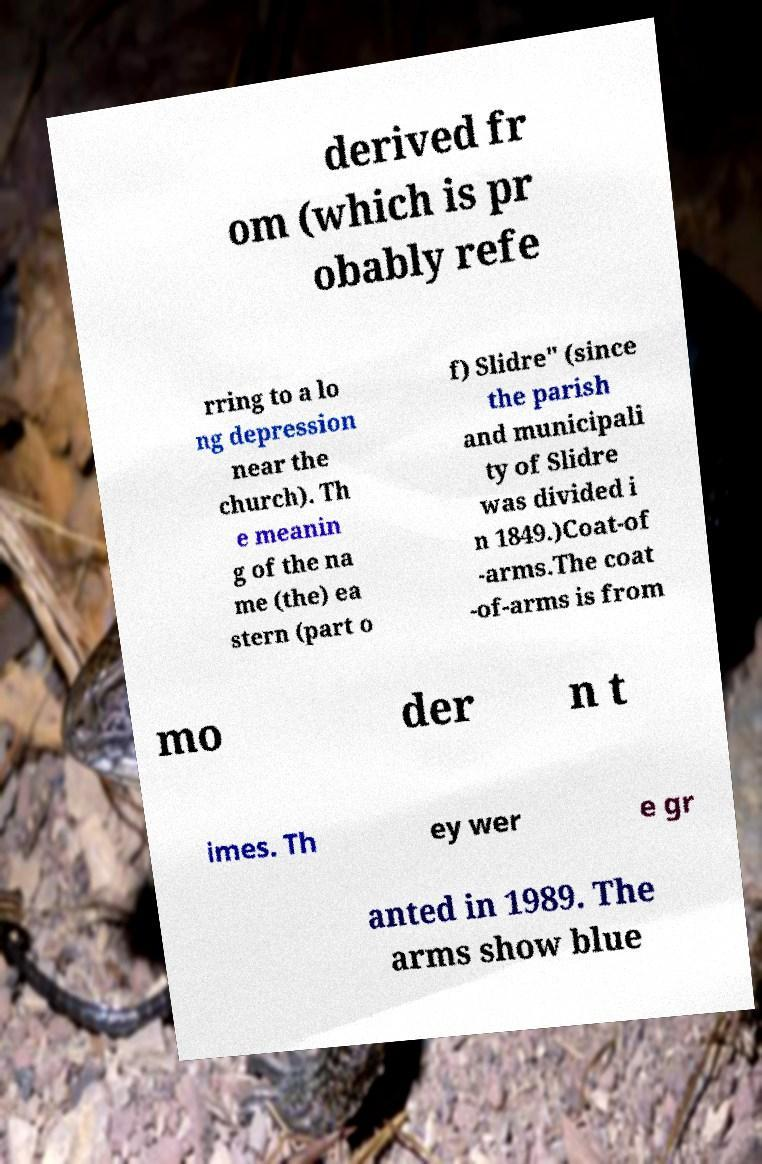Could you extract and type out the text from this image? derived fr om (which is pr obably refe rring to a lo ng depression near the church). Th e meanin g of the na me (the) ea stern (part o f) Slidre" (since the parish and municipali ty of Slidre was divided i n 1849.)Coat-of -arms.The coat -of-arms is from mo der n t imes. Th ey wer e gr anted in 1989. The arms show blue 